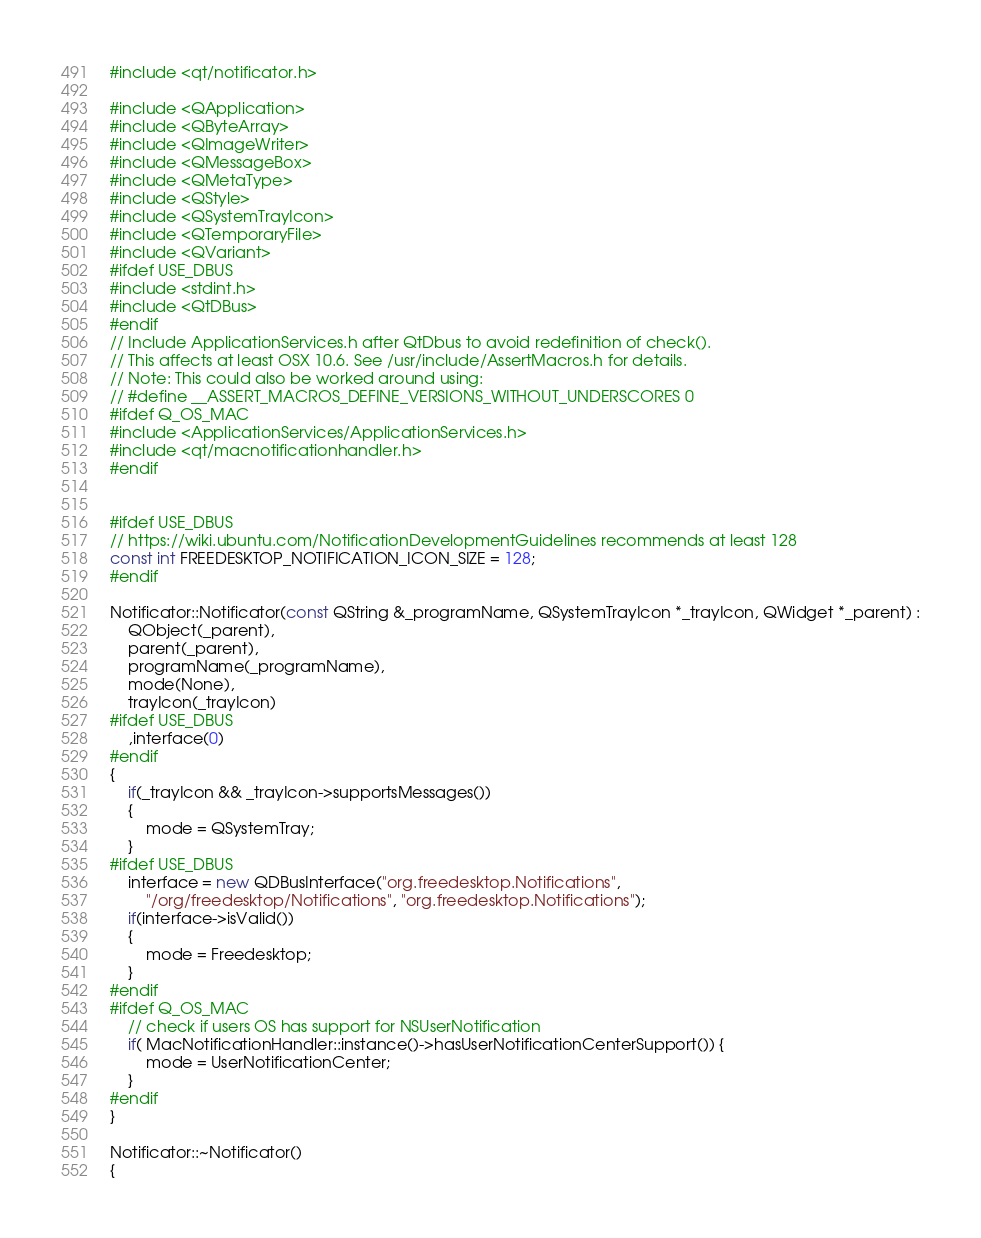<code> <loc_0><loc_0><loc_500><loc_500><_C++_>#include <qt/notificator.h>

#include <QApplication>
#include <QByteArray>
#include <QImageWriter>
#include <QMessageBox>
#include <QMetaType>
#include <QStyle>
#include <QSystemTrayIcon>
#include <QTemporaryFile>
#include <QVariant>
#ifdef USE_DBUS
#include <stdint.h>
#include <QtDBus>
#endif
// Include ApplicationServices.h after QtDbus to avoid redefinition of check().
// This affects at least OSX 10.6. See /usr/include/AssertMacros.h for details.
// Note: This could also be worked around using:
// #define __ASSERT_MACROS_DEFINE_VERSIONS_WITHOUT_UNDERSCORES 0
#ifdef Q_OS_MAC
#include <ApplicationServices/ApplicationServices.h>
#include <qt/macnotificationhandler.h>
#endif


#ifdef USE_DBUS
// https://wiki.ubuntu.com/NotificationDevelopmentGuidelines recommends at least 128
const int FREEDESKTOP_NOTIFICATION_ICON_SIZE = 128;
#endif

Notificator::Notificator(const QString &_programName, QSystemTrayIcon *_trayIcon, QWidget *_parent) :
    QObject(_parent),
    parent(_parent),
    programName(_programName),
    mode(None),
    trayIcon(_trayIcon)
#ifdef USE_DBUS
    ,interface(0)
#endif
{
    if(_trayIcon && _trayIcon->supportsMessages())
    {
        mode = QSystemTray;
    }
#ifdef USE_DBUS
    interface = new QDBusInterface("org.freedesktop.Notifications",
        "/org/freedesktop/Notifications", "org.freedesktop.Notifications");
    if(interface->isValid())
    {
        mode = Freedesktop;
    }
#endif
#ifdef Q_OS_MAC
    // check if users OS has support for NSUserNotification
    if( MacNotificationHandler::instance()->hasUserNotificationCenterSupport()) {
        mode = UserNotificationCenter;
    }
#endif
}

Notificator::~Notificator()
{</code> 